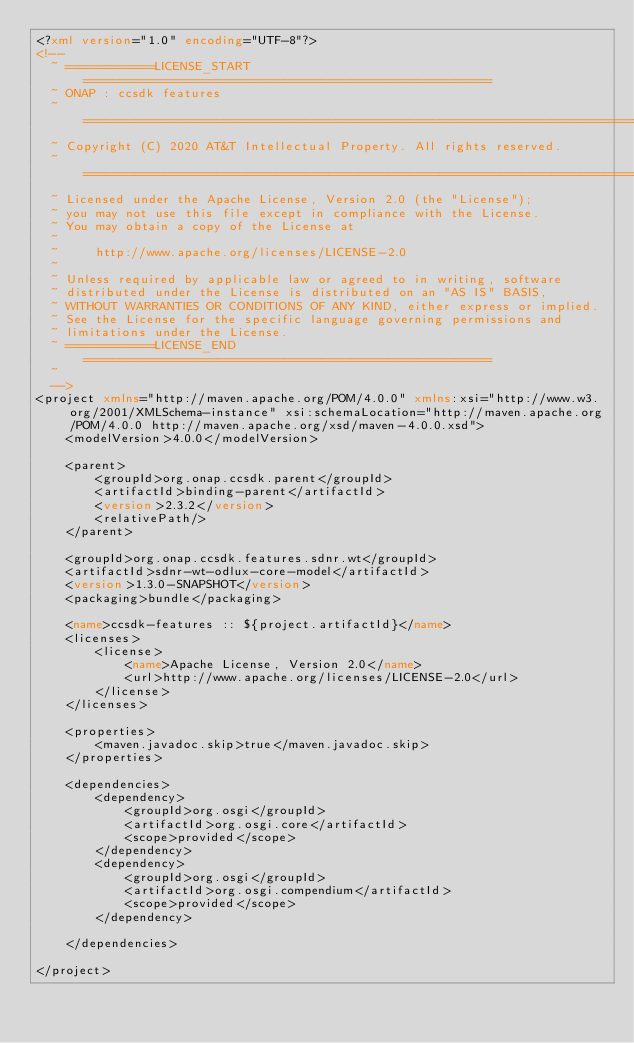Convert code to text. <code><loc_0><loc_0><loc_500><loc_500><_XML_><?xml version="1.0" encoding="UTF-8"?>
<!--
  ~ ============LICENSE_START=======================================================
  ~ ONAP : ccsdk features
  ~ ================================================================================
  ~ Copyright (C) 2020 AT&T Intellectual Property. All rights reserved.
  ~ ================================================================================
  ~ Licensed under the Apache License, Version 2.0 (the "License");
  ~ you may not use this file except in compliance with the License.
  ~ You may obtain a copy of the License at
  ~
  ~     http://www.apache.org/licenses/LICENSE-2.0
  ~
  ~ Unless required by applicable law or agreed to in writing, software
  ~ distributed under the License is distributed on an "AS IS" BASIS,
  ~ WITHOUT WARRANTIES OR CONDITIONS OF ANY KIND, either express or implied.
  ~ See the License for the specific language governing permissions and
  ~ limitations under the License.
  ~ ============LICENSE_END=======================================================
  ~
  -->
<project xmlns="http://maven.apache.org/POM/4.0.0" xmlns:xsi="http://www.w3.org/2001/XMLSchema-instance" xsi:schemaLocation="http://maven.apache.org/POM/4.0.0 http://maven.apache.org/xsd/maven-4.0.0.xsd">
    <modelVersion>4.0.0</modelVersion>

    <parent>
        <groupId>org.onap.ccsdk.parent</groupId>
        <artifactId>binding-parent</artifactId>
        <version>2.3.2</version>
        <relativePath/>
    </parent>

    <groupId>org.onap.ccsdk.features.sdnr.wt</groupId>
    <artifactId>sdnr-wt-odlux-core-model</artifactId>
    <version>1.3.0-SNAPSHOT</version>
    <packaging>bundle</packaging>

    <name>ccsdk-features :: ${project.artifactId}</name>
    <licenses>
        <license>
            <name>Apache License, Version 2.0</name>
            <url>http://www.apache.org/licenses/LICENSE-2.0</url>
        </license>
    </licenses>

    <properties>
        <maven.javadoc.skip>true</maven.javadoc.skip>
    </properties>

    <dependencies>
        <dependency>
            <groupId>org.osgi</groupId>
            <artifactId>org.osgi.core</artifactId>
            <scope>provided</scope>
        </dependency>
        <dependency>
            <groupId>org.osgi</groupId>
            <artifactId>org.osgi.compendium</artifactId>
            <scope>provided</scope>
        </dependency>

    </dependencies>

</project>
</code> 